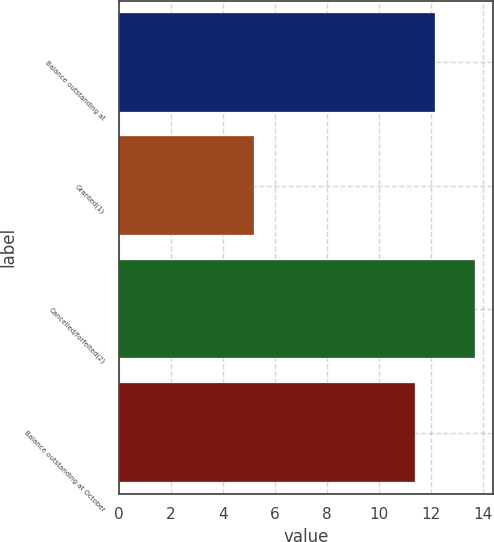<chart> <loc_0><loc_0><loc_500><loc_500><bar_chart><fcel>Balance outstanding at<fcel>Granted(1)<fcel>Cancelled/forfeited(2)<fcel>Balance outstanding at October<nl><fcel>12.16<fcel>5.19<fcel>13.72<fcel>11.38<nl></chart> 